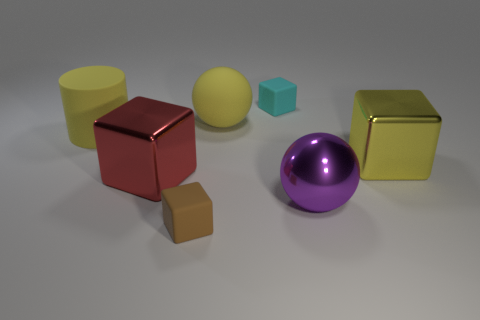How many shiny objects are either big brown objects or tiny brown cubes?
Provide a succinct answer. 0. What number of other tiny things have the same shape as the yellow metallic object?
Provide a succinct answer. 2. There is a large ball that is the same color as the big cylinder; what material is it?
Ensure brevity in your answer.  Rubber. There is a purple metal thing in front of the big red shiny block; is it the same size as the matte block behind the big matte cylinder?
Ensure brevity in your answer.  No. The large shiny thing that is in front of the red object has what shape?
Offer a terse response. Sphere. There is a brown object that is the same shape as the red metal object; what is its material?
Provide a succinct answer. Rubber. There is a block behind the yellow metal block; is its size the same as the red shiny cube?
Provide a short and direct response. No. There is a big rubber cylinder; how many red things are on the right side of it?
Offer a very short reply. 1. Are there fewer objects that are in front of the yellow rubber cylinder than cyan blocks to the right of the yellow metal block?
Ensure brevity in your answer.  No. What number of small cyan blocks are there?
Your answer should be very brief. 1. 